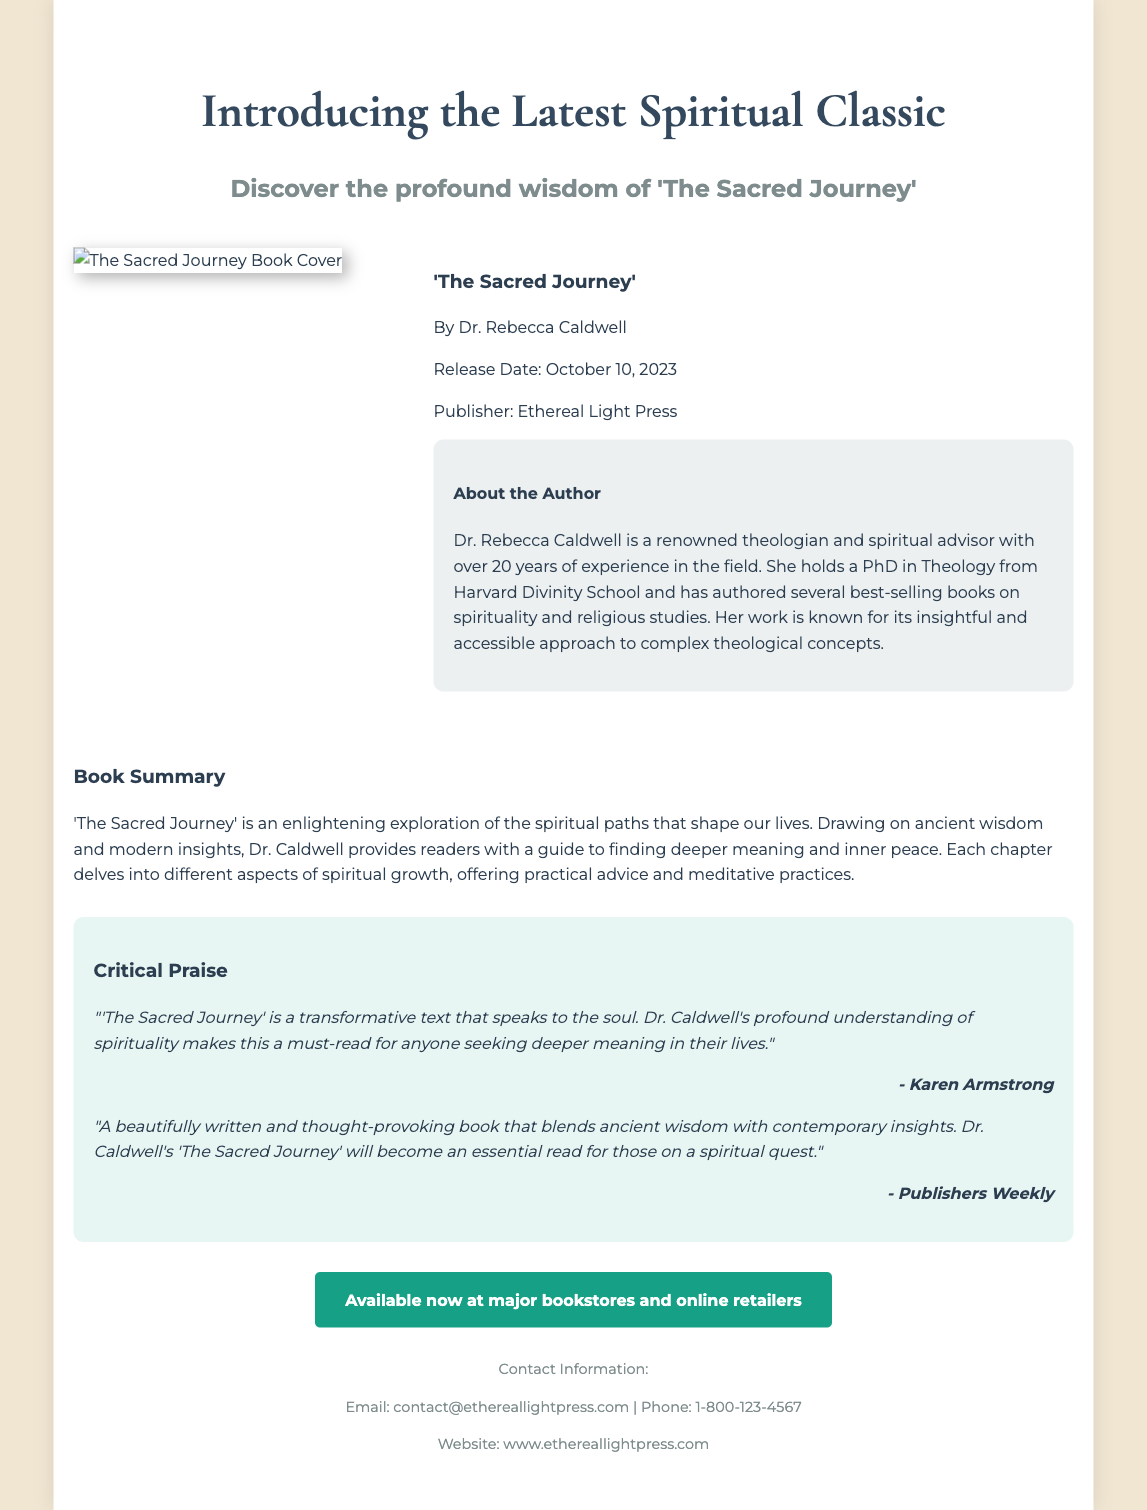what is the title of the book? The title of the book is prominently displayed as part of the main heading.
Answer: The Sacred Journey who is the author of the book? The author's name is mentioned alongside the book title and details.
Answer: Dr. Rebecca Caldwell what is the release date of the book? The release date is mentioned in the book details section.
Answer: October 10, 2023 which publisher released the book? The publisher's name is provided in the book details section.
Answer: Ethereal Light Press what is the main theme of 'The Sacred Journey'? The summary describes the main theme of the book in a single sentence.
Answer: Spiritual growth who provided critical praise for the book? The critical praise section lists notable figures who reviewed the book.
Answer: Karen Armstrong how many years of experience does Dr. Caldwell have? The author bio section states her years of experience in the field.
Answer: 20 years what is the website for Ethereal Light Press? The website is mentioned in the footer of the document.
Answer: www.ethereallightpress.com where can the book be purchased? The call-to-action section directs readers on where to find the book.
Answer: Major bookstores and online retailers 